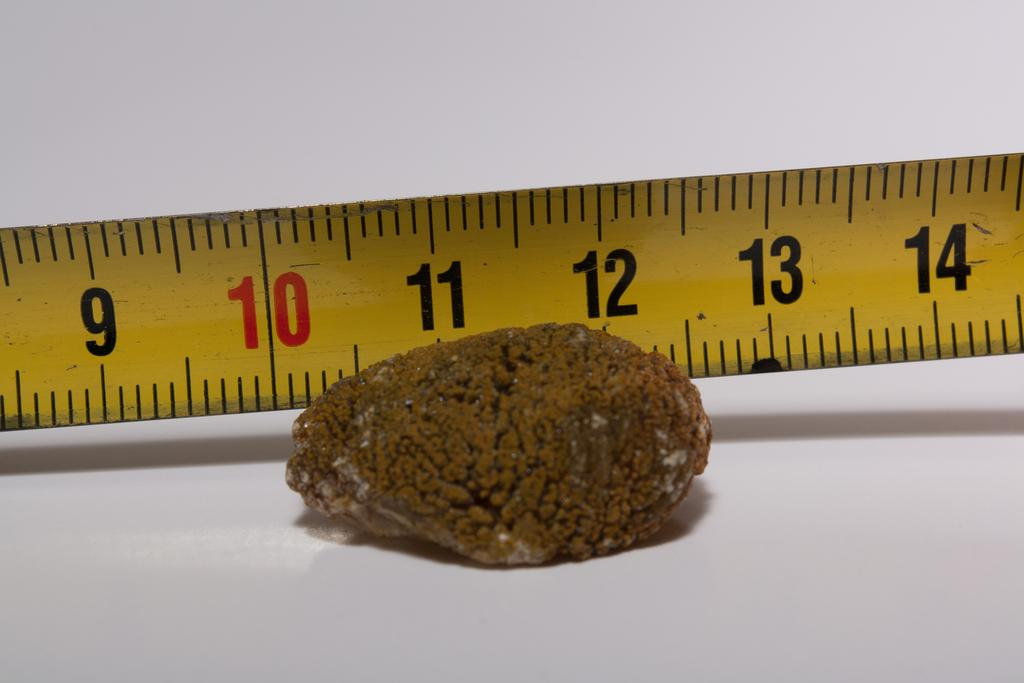<image>
Provide a brief description of the given image. the brown lump is being measured at a little over 2 inches 